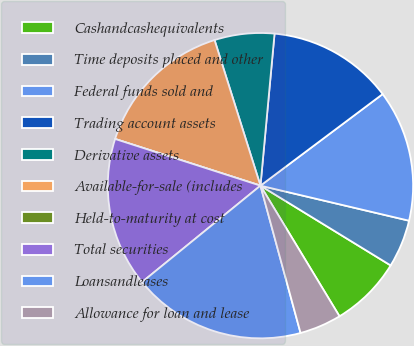Convert chart. <chart><loc_0><loc_0><loc_500><loc_500><pie_chart><fcel>Cashandcashequivalents<fcel>Time deposits placed and other<fcel>Federal funds sold and<fcel>Trading account assets<fcel>Derivative assets<fcel>Available-for-sale (includes<fcel>Held-to-maturity at cost<fcel>Total securities<fcel>Loansandleases<fcel>Allowance for loan and lease<nl><fcel>7.59%<fcel>5.06%<fcel>13.92%<fcel>13.29%<fcel>6.33%<fcel>15.19%<fcel>0.0%<fcel>15.82%<fcel>18.35%<fcel>4.43%<nl></chart> 